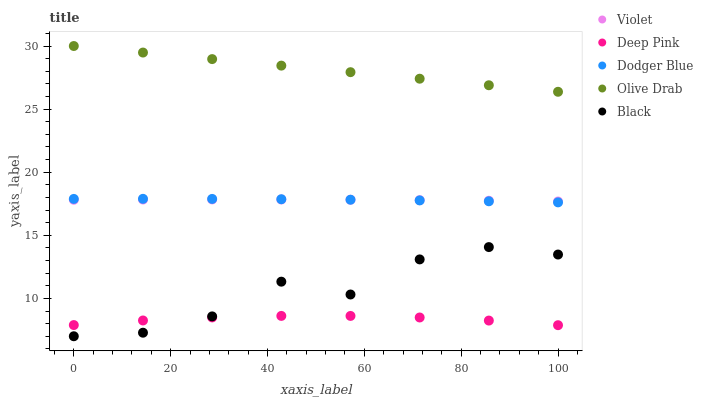Does Deep Pink have the minimum area under the curve?
Answer yes or no. Yes. Does Olive Drab have the maximum area under the curve?
Answer yes or no. Yes. Does Dodger Blue have the minimum area under the curve?
Answer yes or no. No. Does Dodger Blue have the maximum area under the curve?
Answer yes or no. No. Is Olive Drab the smoothest?
Answer yes or no. Yes. Is Black the roughest?
Answer yes or no. Yes. Is Deep Pink the smoothest?
Answer yes or no. No. Is Deep Pink the roughest?
Answer yes or no. No. Does Black have the lowest value?
Answer yes or no. Yes. Does Deep Pink have the lowest value?
Answer yes or no. No. Does Olive Drab have the highest value?
Answer yes or no. Yes. Does Dodger Blue have the highest value?
Answer yes or no. No. Is Black less than Olive Drab?
Answer yes or no. Yes. Is Dodger Blue greater than Deep Pink?
Answer yes or no. Yes. Does Black intersect Deep Pink?
Answer yes or no. Yes. Is Black less than Deep Pink?
Answer yes or no. No. Is Black greater than Deep Pink?
Answer yes or no. No. Does Black intersect Olive Drab?
Answer yes or no. No. 